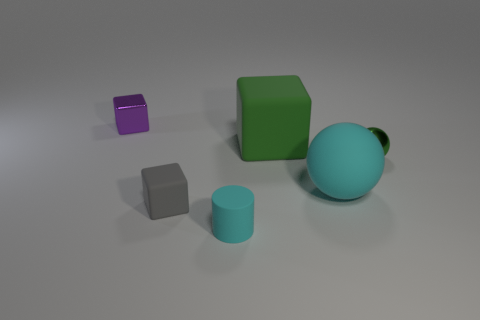Does the green thing behind the small metallic ball have the same material as the thing on the right side of the big cyan sphere?
Offer a very short reply. No. What shape is the matte thing that is the same color as the small metal ball?
Your answer should be compact. Cube. How many objects are either small metallic objects that are to the left of the rubber cylinder or matte cubes that are right of the small matte cylinder?
Give a very brief answer. 2. Do the large thing behind the big ball and the metallic object on the right side of the purple metallic thing have the same color?
Offer a very short reply. Yes. What shape is the small object that is right of the gray matte object and in front of the small green metallic ball?
Give a very brief answer. Cylinder. There is a rubber cylinder that is the same size as the gray block; what is its color?
Provide a short and direct response. Cyan. Is there a large thing of the same color as the large cube?
Provide a succinct answer. No. Is the size of the cyan matte thing that is behind the small cyan cylinder the same as the rubber cube behind the large matte sphere?
Provide a succinct answer. Yes. There is a small thing that is both to the left of the small cyan matte object and in front of the green cube; what is its material?
Your answer should be very brief. Rubber. What is the size of the object that is the same color as the big block?
Give a very brief answer. Small. 